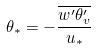<formula> <loc_0><loc_0><loc_500><loc_500>\theta _ { * } = - \frac { \overline { w ^ { \prime } \theta _ { v } ^ { \prime } } } { u _ { * } }</formula> 